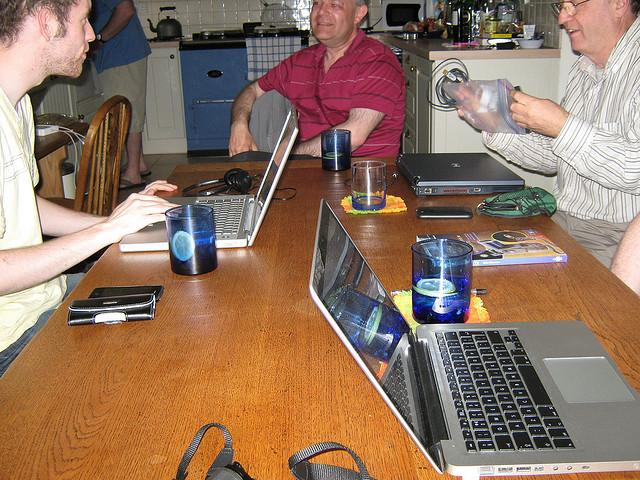Why is everyone at the table using laptops? Please explain your reasoning. they're working. They are all working on stuff. 